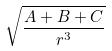<formula> <loc_0><loc_0><loc_500><loc_500>\sqrt { \frac { A + B + C } { r ^ { 3 } } }</formula> 